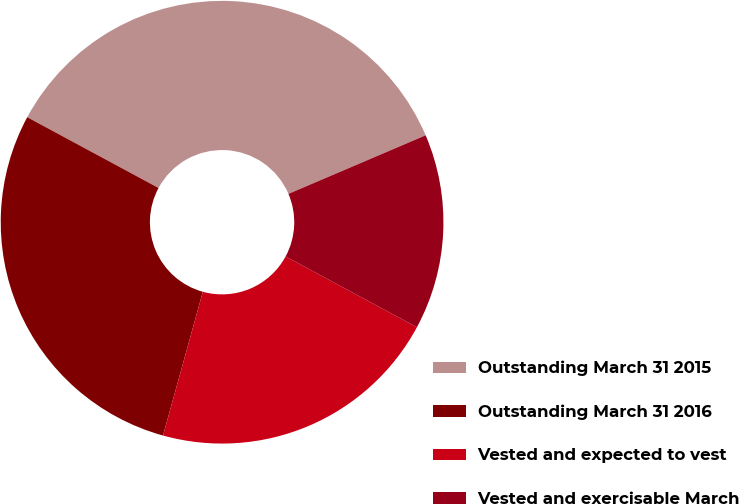Convert chart. <chart><loc_0><loc_0><loc_500><loc_500><pie_chart><fcel>Outstanding March 31 2015<fcel>Outstanding March 31 2016<fcel>Vested and expected to vest<fcel>Vested and exercisable March<nl><fcel>35.71%<fcel>28.57%<fcel>21.43%<fcel>14.29%<nl></chart> 